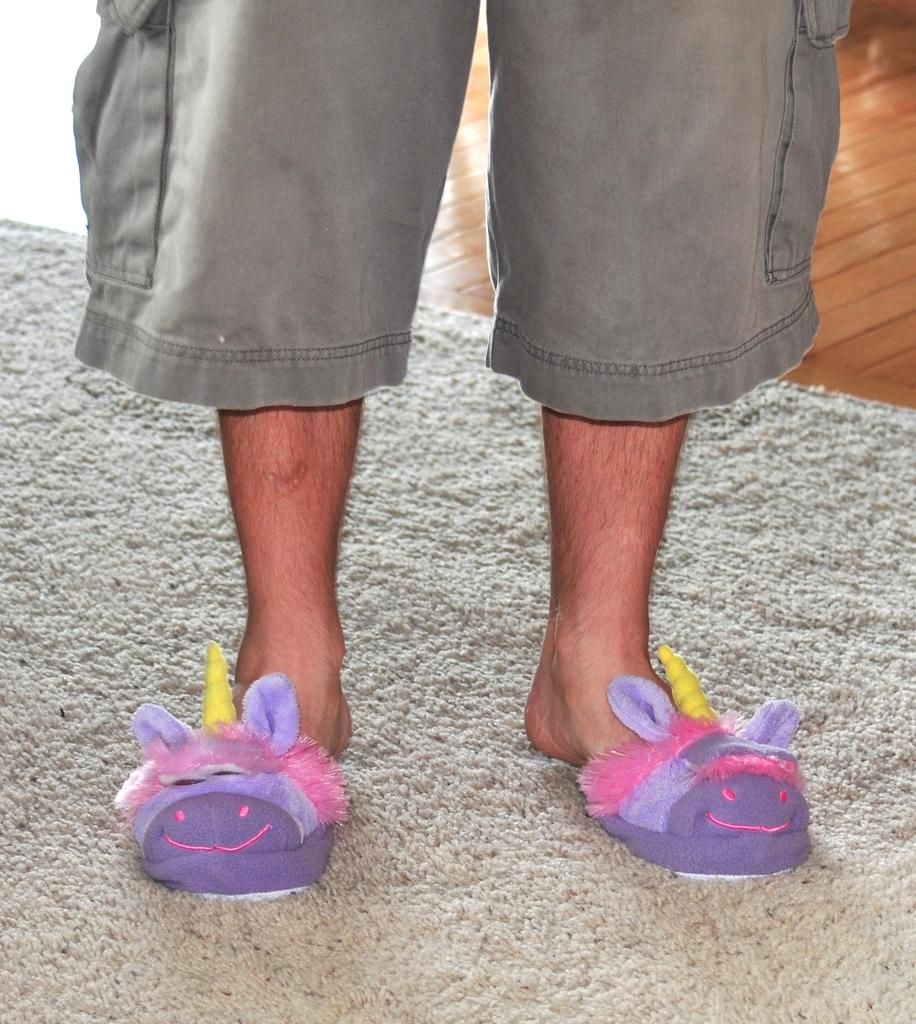What body parts are visible in the image? There are person's legs visible in the image. What is the surface beneath the person's legs? There is a floor in the image. What type of flooring is present in the image? The floor has a carpet on it. What invention is being demonstrated by the person's son in the image? There is no person's son present in the image, and no invention is being demonstrated. 